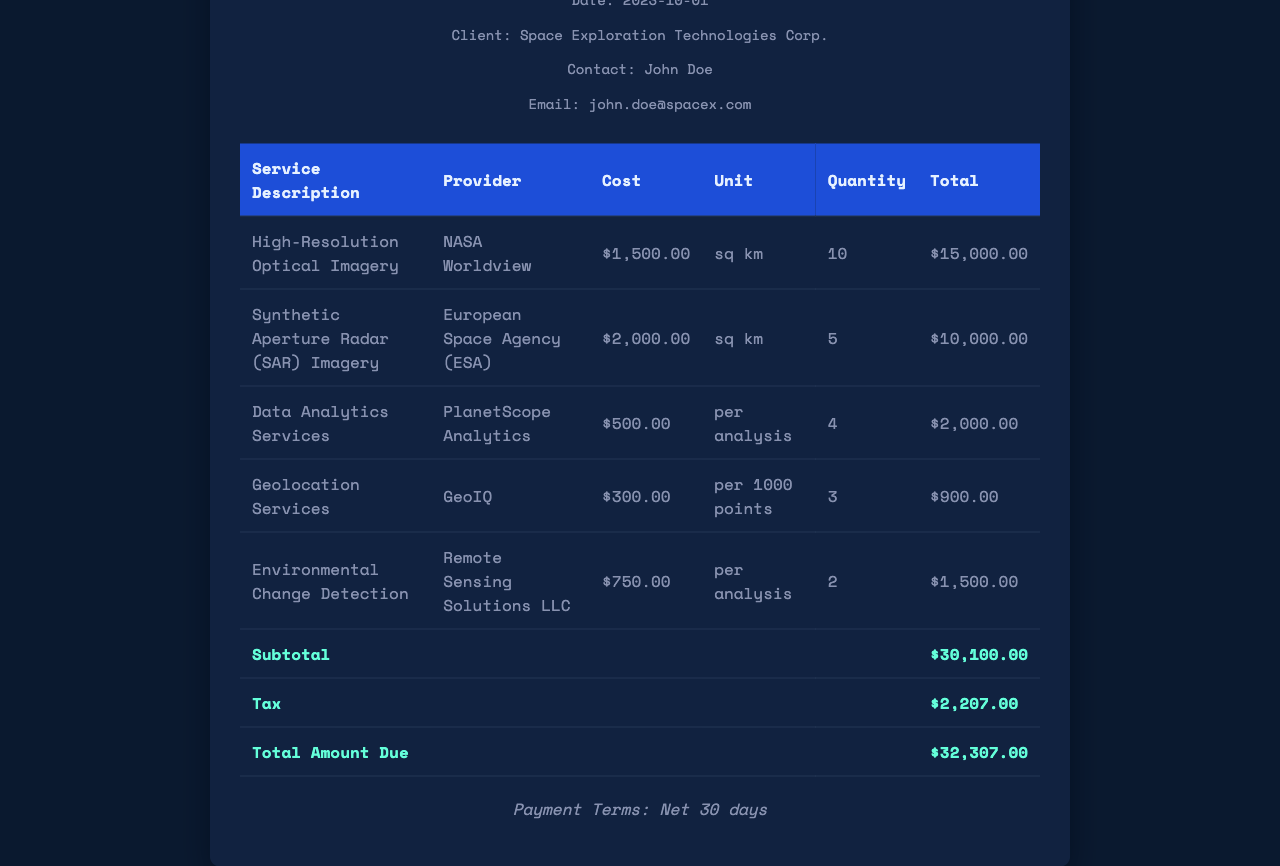What is the date of the receipt? The date of the receipt is mentioned at the top of the document.
Answer: 2023-10-01 Who is the client? The client information is provided under the client details section in the document.
Answer: Space Exploration Technologies Corp What is the cost of High-Resolution Optical Imagery? The cost is listed in the itemized services table under the corresponding service description.
Answer: $1,500.00 How many units of Geolocation Services were requested? The quantity for Geolocation Services is specified in the table.
Answer: 3 What is the total amount due? The total is indicated in the summary section at the bottom of the expense table.
Answer: $32,307.00 Which provider offered Data Analytics Services? The provider's name for Data Analytics Services is listed in the service table next to the service description.
Answer: PlanetScope Analytics What is the subtotal before tax? The subtotal is provided in the document as a distinct category in the total row.
Answer: $30,100.00 How much tax was charged? The tax amount is displayed as a separate line in the total section of the receipt.
Answer: $2,207.00 What are the payment terms? The payment terms are located at the bottom of the receipt under payment terms.
Answer: Net 30 days 